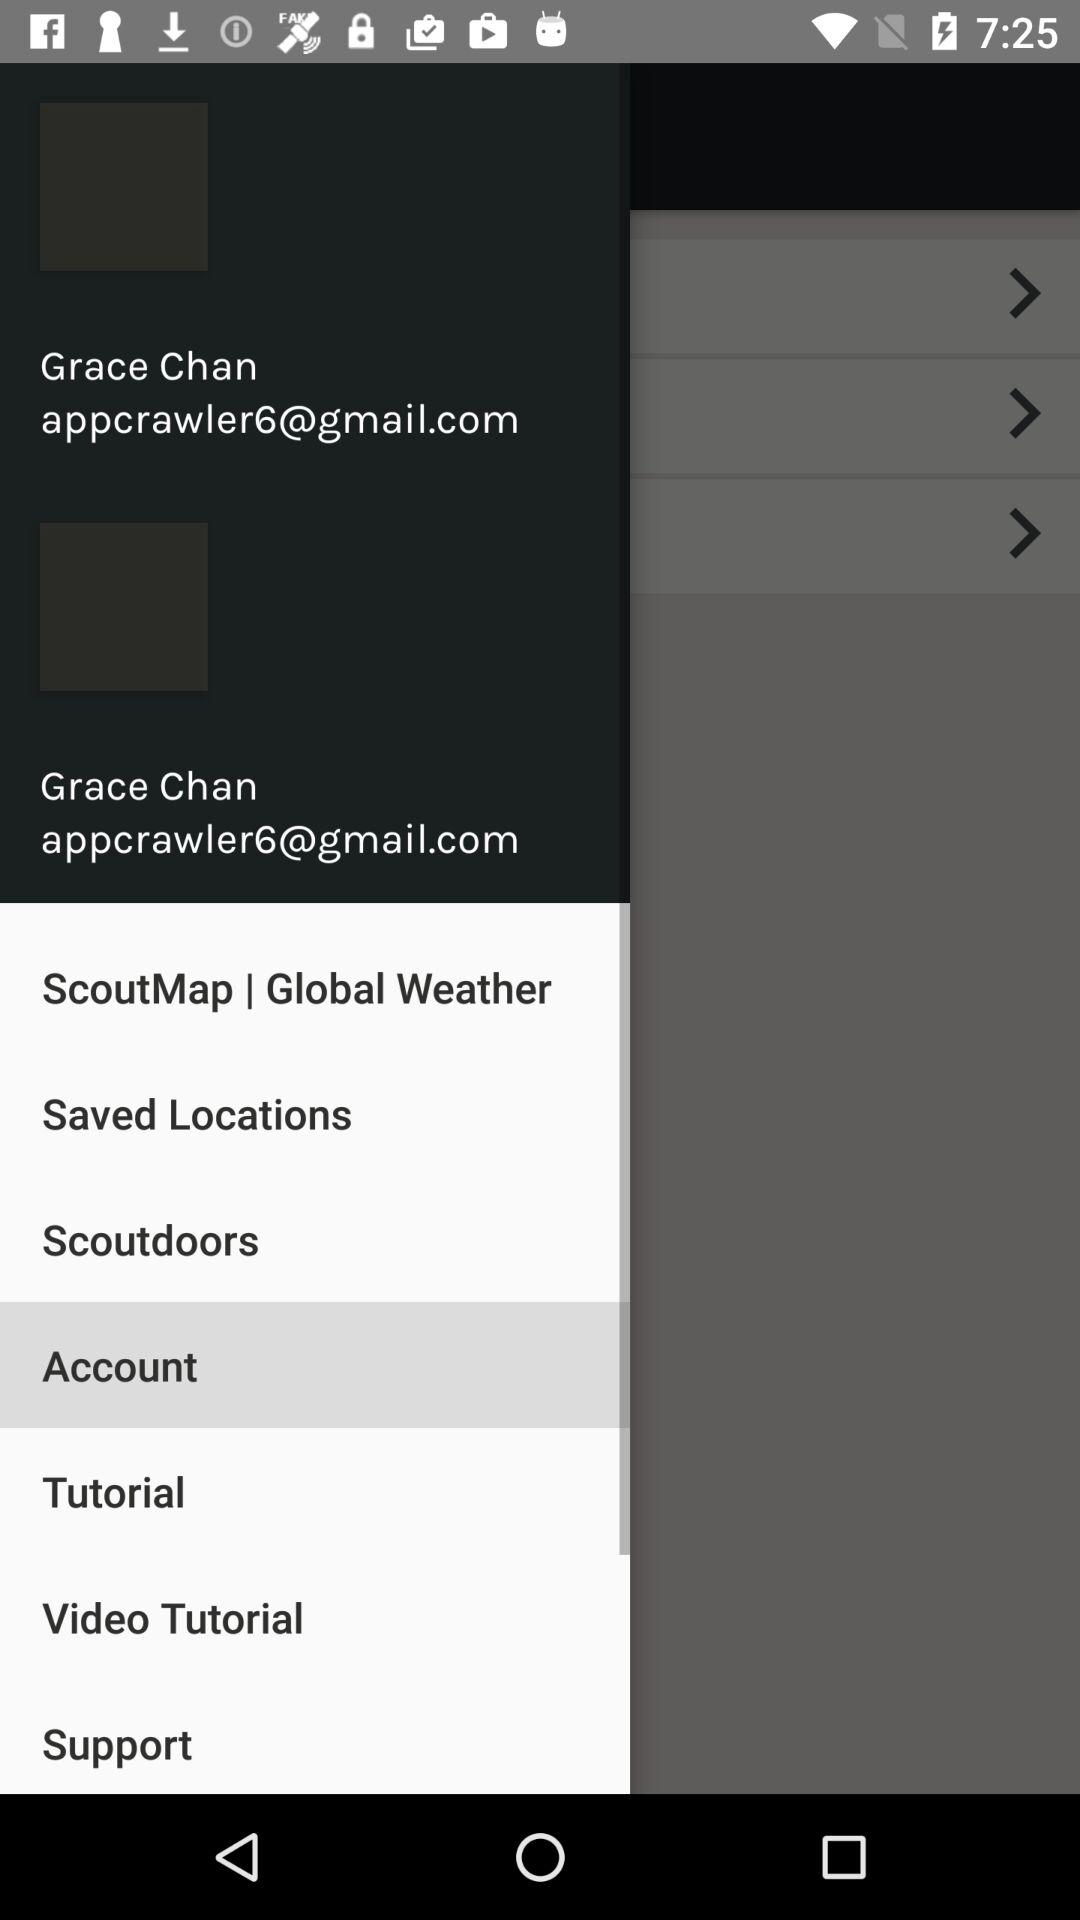What are the saved locations?
When the provided information is insufficient, respond with <no answer>. <no answer> 